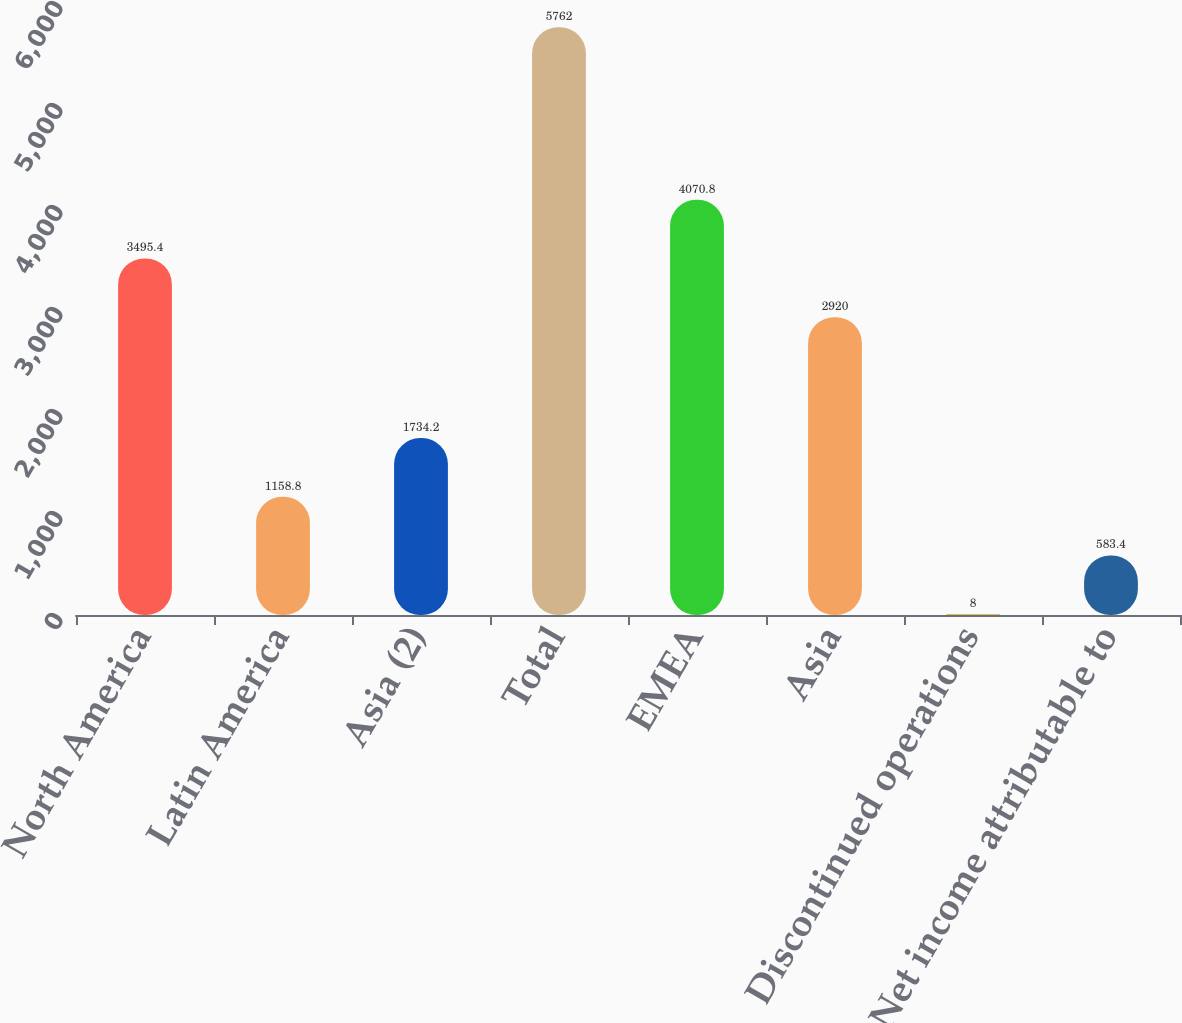Convert chart to OTSL. <chart><loc_0><loc_0><loc_500><loc_500><bar_chart><fcel>North America<fcel>Latin America<fcel>Asia (2)<fcel>Total<fcel>EMEA<fcel>Asia<fcel>Discontinued operations<fcel>Net income attributable to<nl><fcel>3495.4<fcel>1158.8<fcel>1734.2<fcel>5762<fcel>4070.8<fcel>2920<fcel>8<fcel>583.4<nl></chart> 